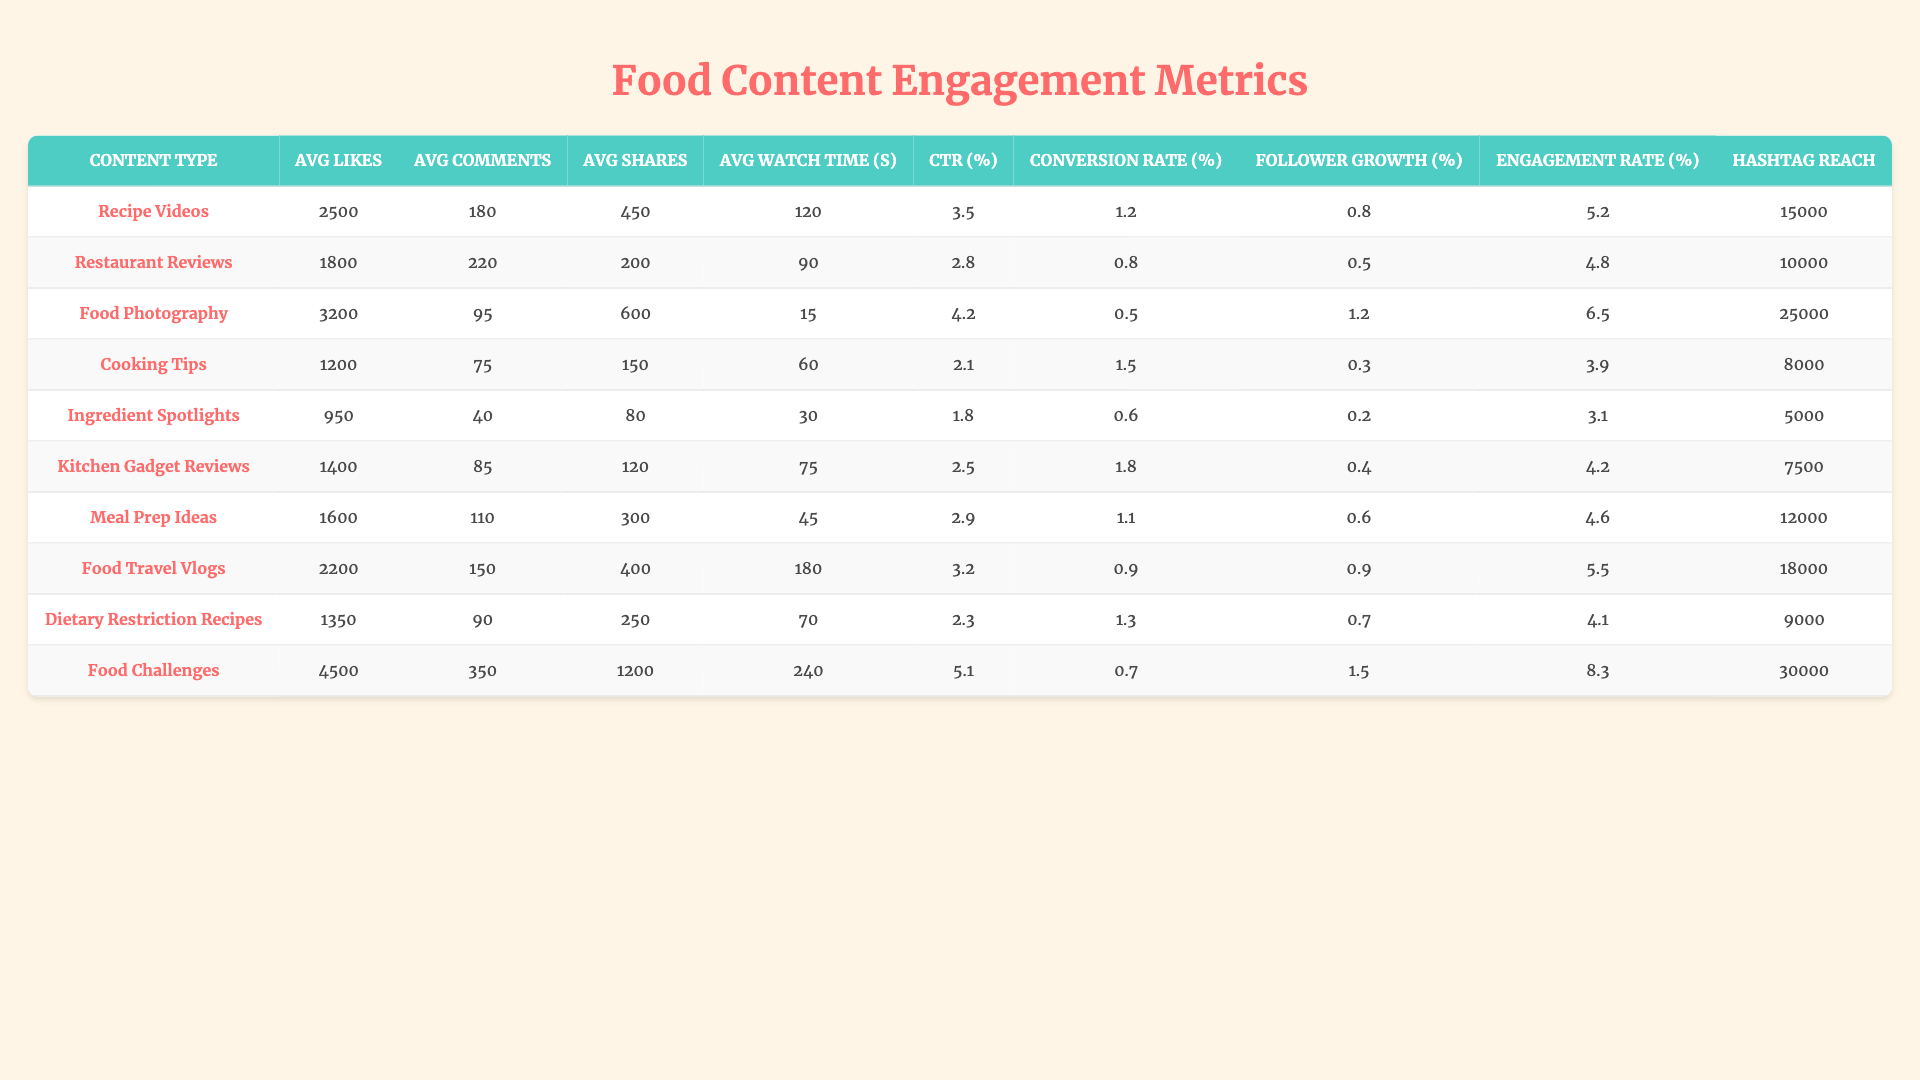What type of food content has the highest average likes? By examining the table, we find that "Food Challenges" has the highest average likes, with a value of 4500.
Answer: Food Challenges What is the average engagement rate for Recipe Videos? The engagement rate for Recipe Videos is listed in the table as 5.2 percent.
Answer: 5.2% Which content type has the lowest average shares? Looking at the "Average Shares" column, "Ingredient Spotlights" has the lowest average shares at 80.
Answer: Ingredient Spotlights What is the total average watch time for Cooking Tips and Ingredient Spotlights combined? The average watch time for Cooking Tips is 60 seconds and for Ingredient Spotlights is 30 seconds. Adding these gives 60 + 30 = 90 seconds.
Answer: 90 seconds Is the click-through rate for Restaurant Reviews higher than for Cooking Tips? The click-through rate for Restaurant Reviews is 2.8%, while for Cooking Tips, it is 2.1%. Since 2.8% is greater than 2.1%, the statement is true.
Answer: Yes What is the average conversion rate across all content types? We sum all the conversion rates: 1.2 + 0.8 + 0.5 + 1.5 + 0.6 + 1.8 + 1.1 + 0.9 + 1.3 + 0.7 = 10.3, and divide by 10 (the number of types) to get 10.3 / 10 = 1.03%.
Answer: 1.03% Which content type has the highest hashtag reach? The table shows "Food Challenges" with a hashtag reach of 30000, making it the highest.
Answer: Food Challenges Which content type has a higher average comments: Meal Prep Ideas or Ingredient Spotlights? Meal Prep Ideas has an average of 110 comments and Ingredient Spotlights has 40. Since 110 is greater than 40, Meal Prep Ideas has more comments.
Answer: Meal Prep Ideas What is the difference in average likes between Food Photography and Kitchen Gadget Reviews? Food Photography has 3200 likes, and Kitchen Gadget Reviews has 1400 likes. The difference is 3200 - 1400 = 1800.
Answer: 1800 Which content type has both the highest average shares and the highest average watch time? "Food Challenges" has the highest average shares (1200) and an average watch time of 240 seconds, making it the content type that qualifies for both highest metrics.
Answer: Food Challenges 